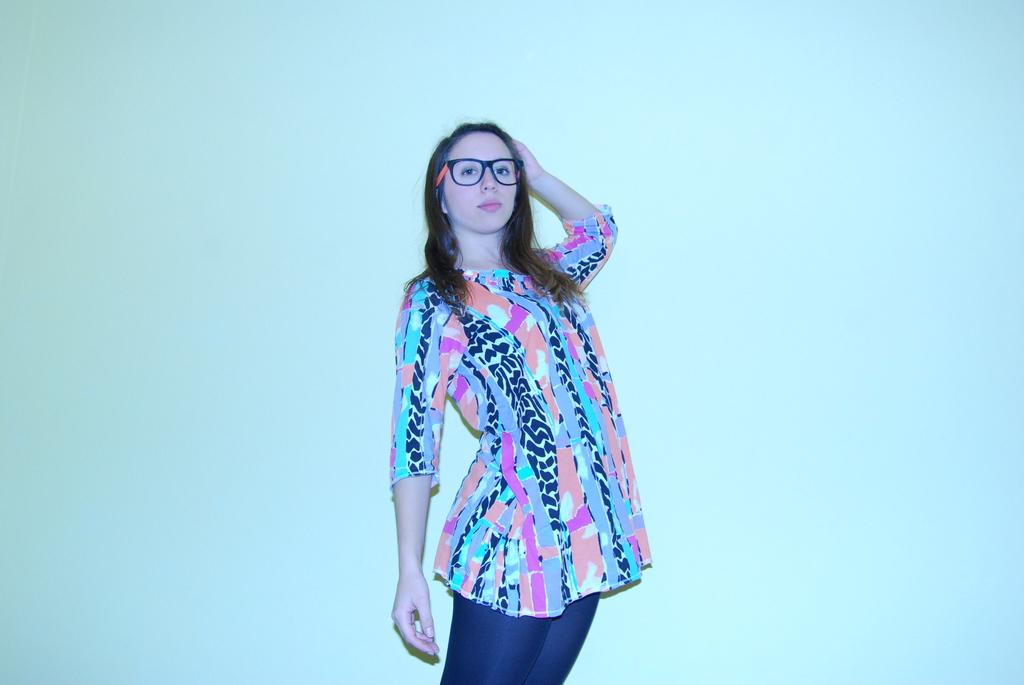Who or what is the main subject in the image? There is a person in the image. Can you describe the person's position in relation to the image? The person is in front of the image. What can be seen behind the person in the image? There is a wall behind the person. How many buttons can be seen on the wall in the image? There is no mention of buttons on the wall in the image, so we cannot determine their number. 